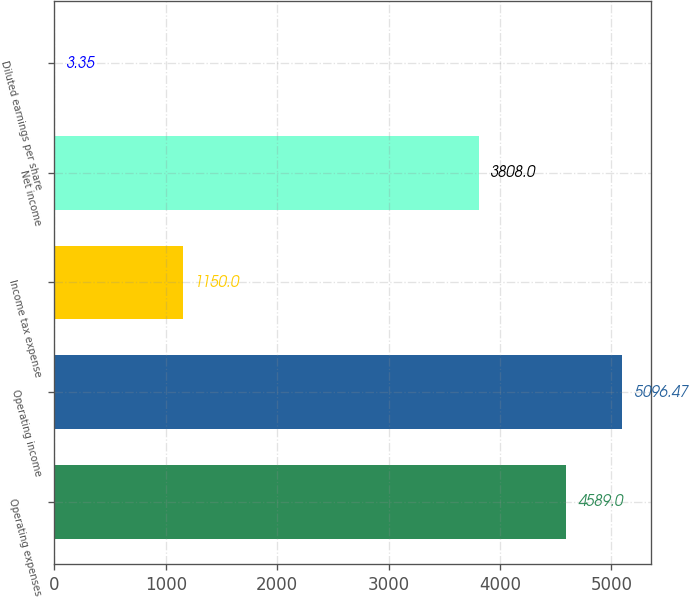Convert chart to OTSL. <chart><loc_0><loc_0><loc_500><loc_500><bar_chart><fcel>Operating expenses<fcel>Operating income<fcel>Income tax expense<fcel>Net income<fcel>Diluted earnings per share<nl><fcel>4589<fcel>5096.47<fcel>1150<fcel>3808<fcel>3.35<nl></chart> 